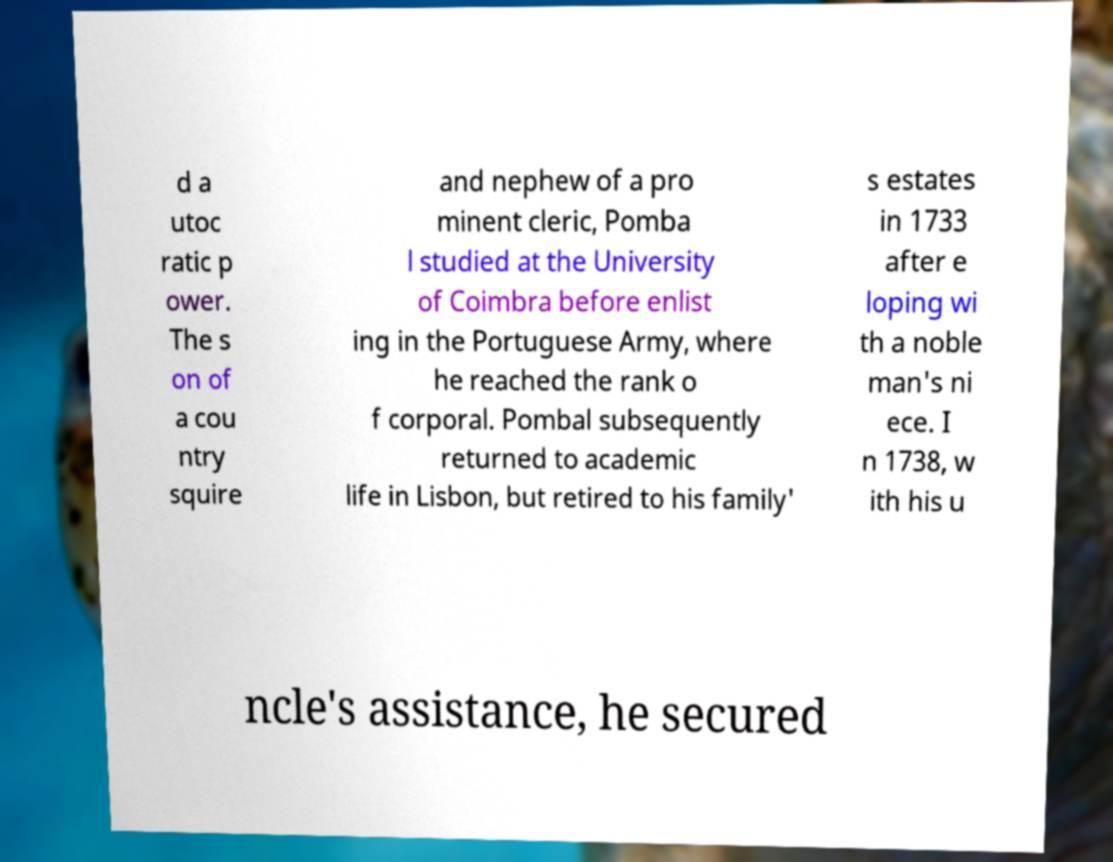Please identify and transcribe the text found in this image. d a utoc ratic p ower. The s on of a cou ntry squire and nephew of a pro minent cleric, Pomba l studied at the University of Coimbra before enlist ing in the Portuguese Army, where he reached the rank o f corporal. Pombal subsequently returned to academic life in Lisbon, but retired to his family' s estates in 1733 after e loping wi th a noble man's ni ece. I n 1738, w ith his u ncle's assistance, he secured 